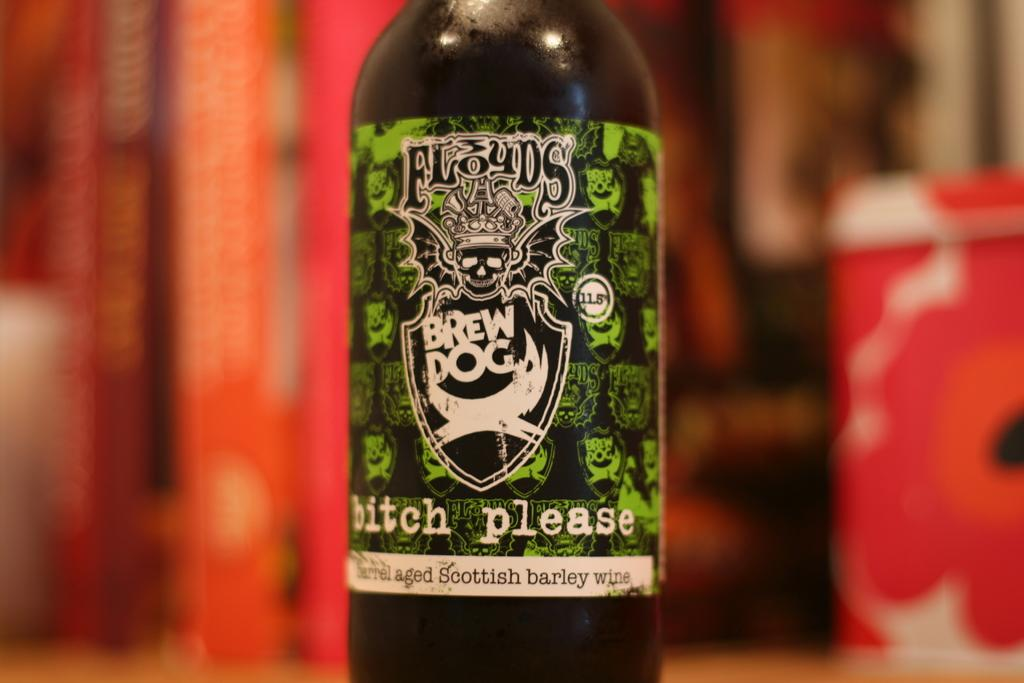<image>
Present a compact description of the photo's key features. Close up of a Brew Dog bitch please beer bottle sitting on a table. 